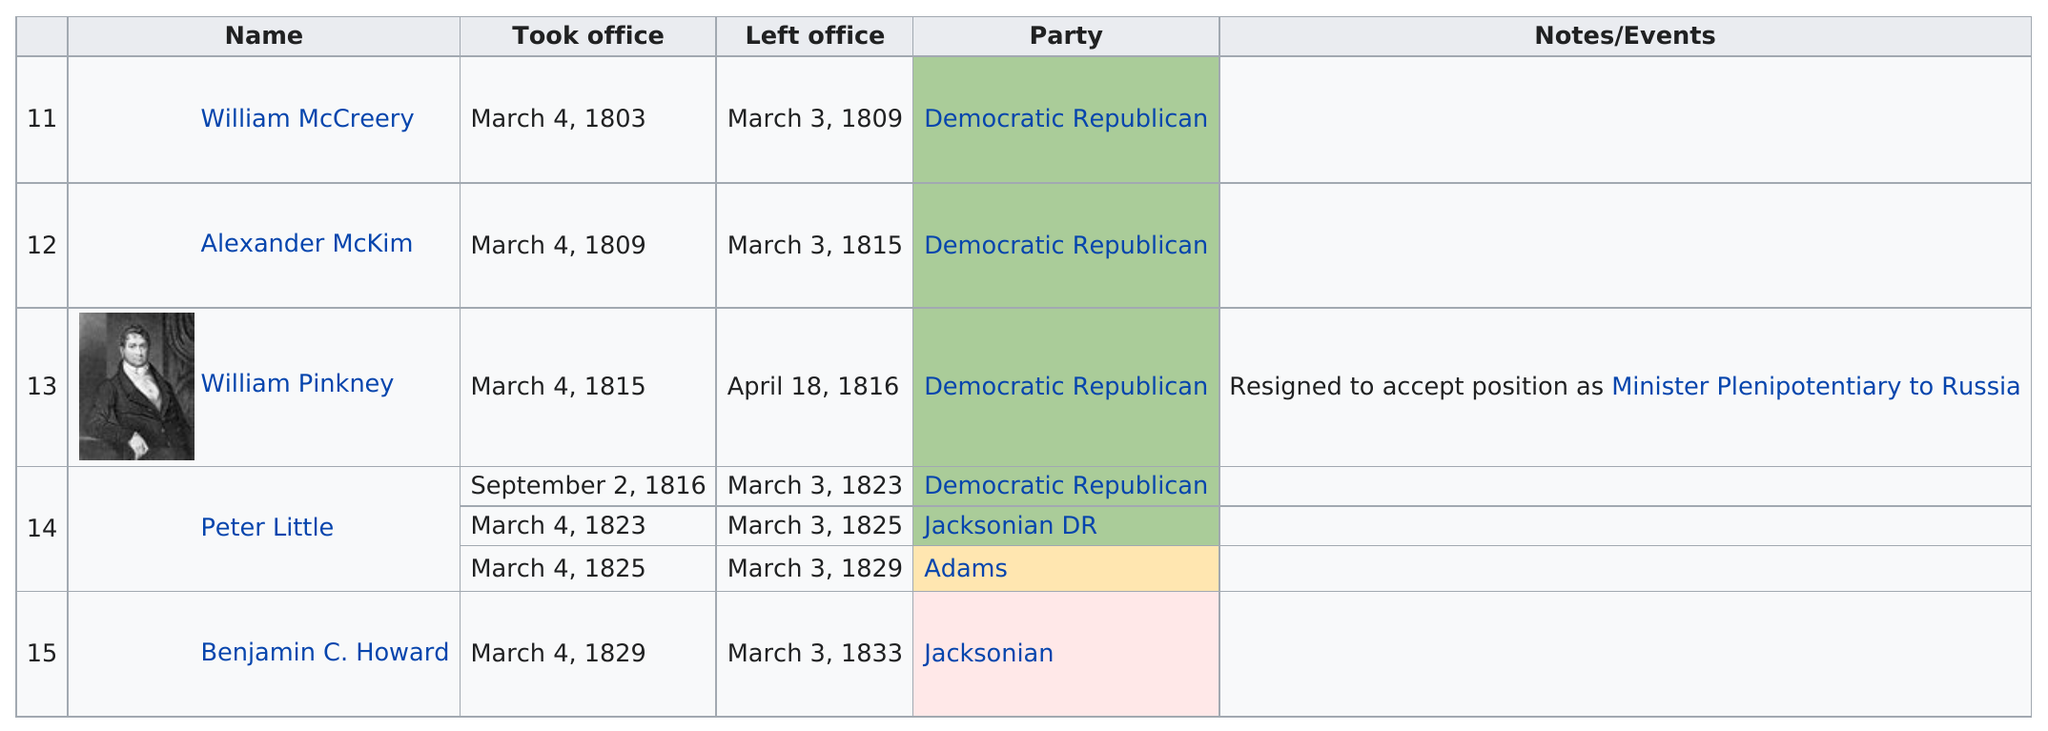Specify some key components in this picture. William McCreery was the first person to take office in 1803. Peter Little is the congressman who has taken office the most times. Alexander McKim served in office for a period of 6 years. William Pinkney was a congressman who sat for the least number of years. It is estimated that approximately 5 people served in this office. 